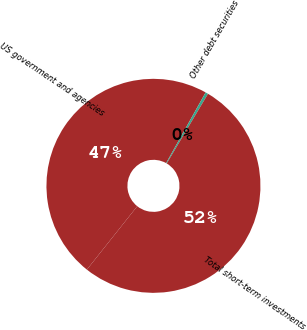Convert chart to OTSL. <chart><loc_0><loc_0><loc_500><loc_500><pie_chart><fcel>US government and agencies<fcel>Other debt securities<fcel>Total short-term investments<nl><fcel>47.42%<fcel>0.41%<fcel>52.17%<nl></chart> 